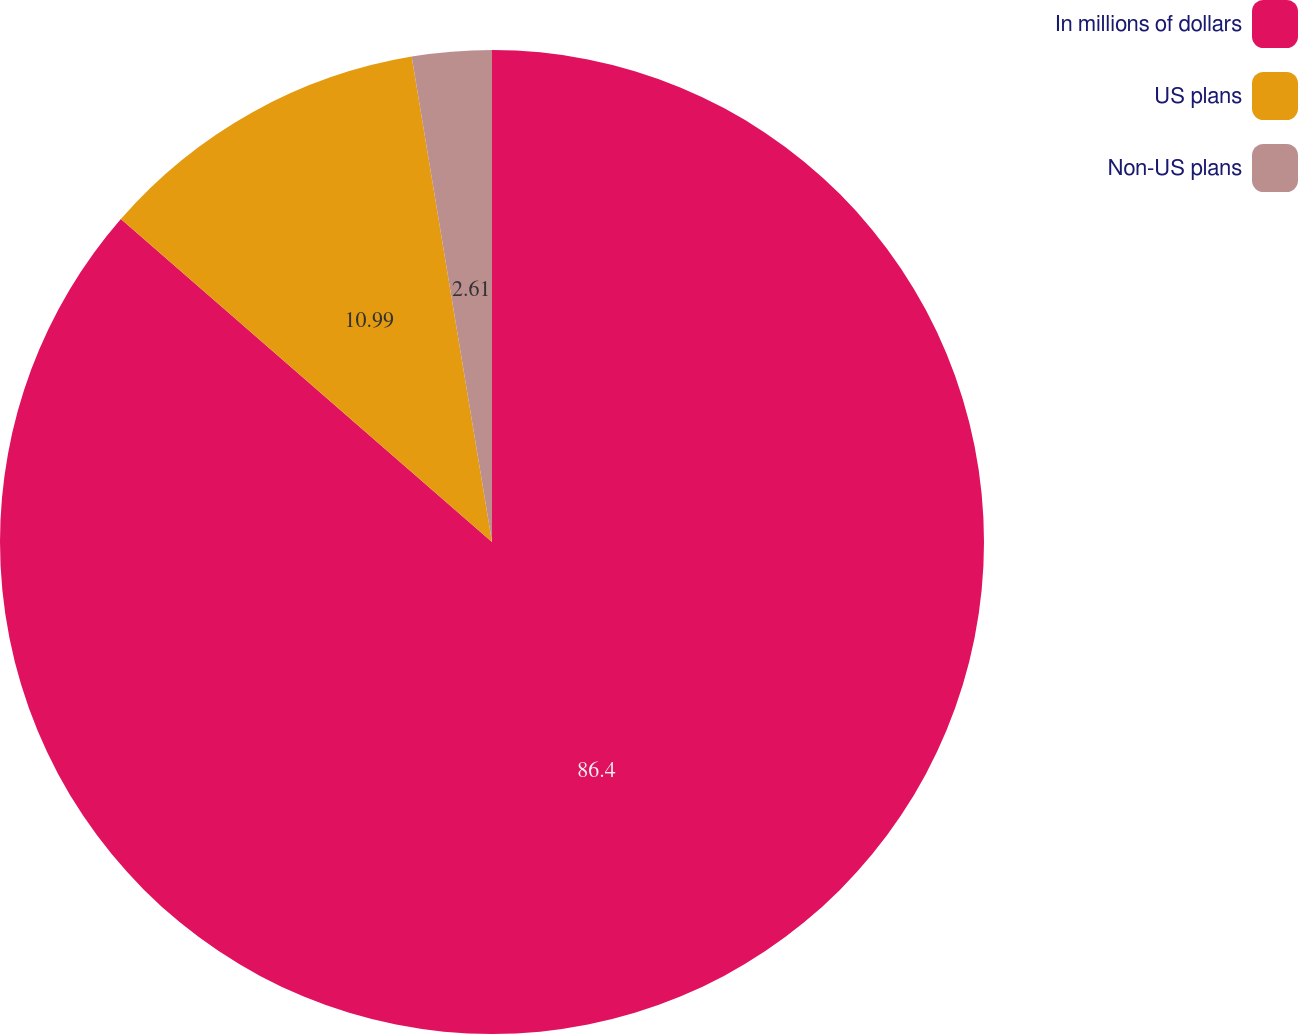<chart> <loc_0><loc_0><loc_500><loc_500><pie_chart><fcel>In millions of dollars<fcel>US plans<fcel>Non-US plans<nl><fcel>86.39%<fcel>10.99%<fcel>2.61%<nl></chart> 